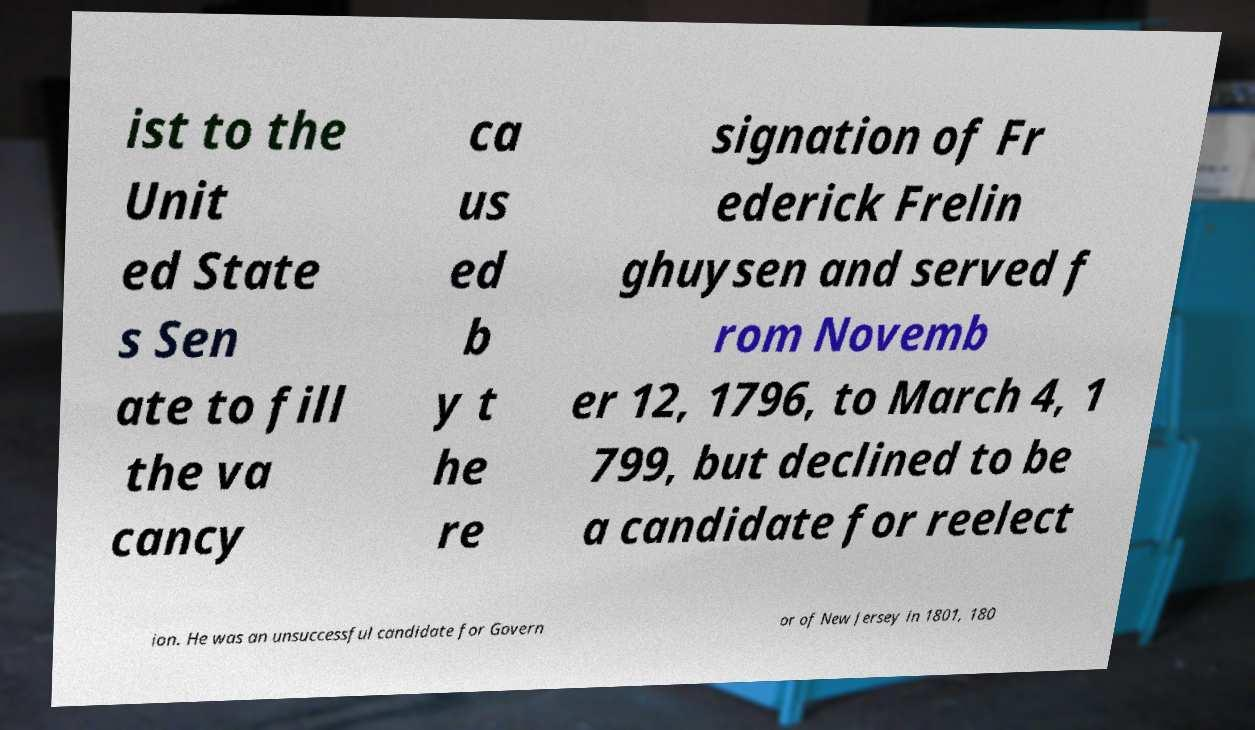I need the written content from this picture converted into text. Can you do that? ist to the Unit ed State s Sen ate to fill the va cancy ca us ed b y t he re signation of Fr ederick Frelin ghuysen and served f rom Novemb er 12, 1796, to March 4, 1 799, but declined to be a candidate for reelect ion. He was an unsuccessful candidate for Govern or of New Jersey in 1801, 180 